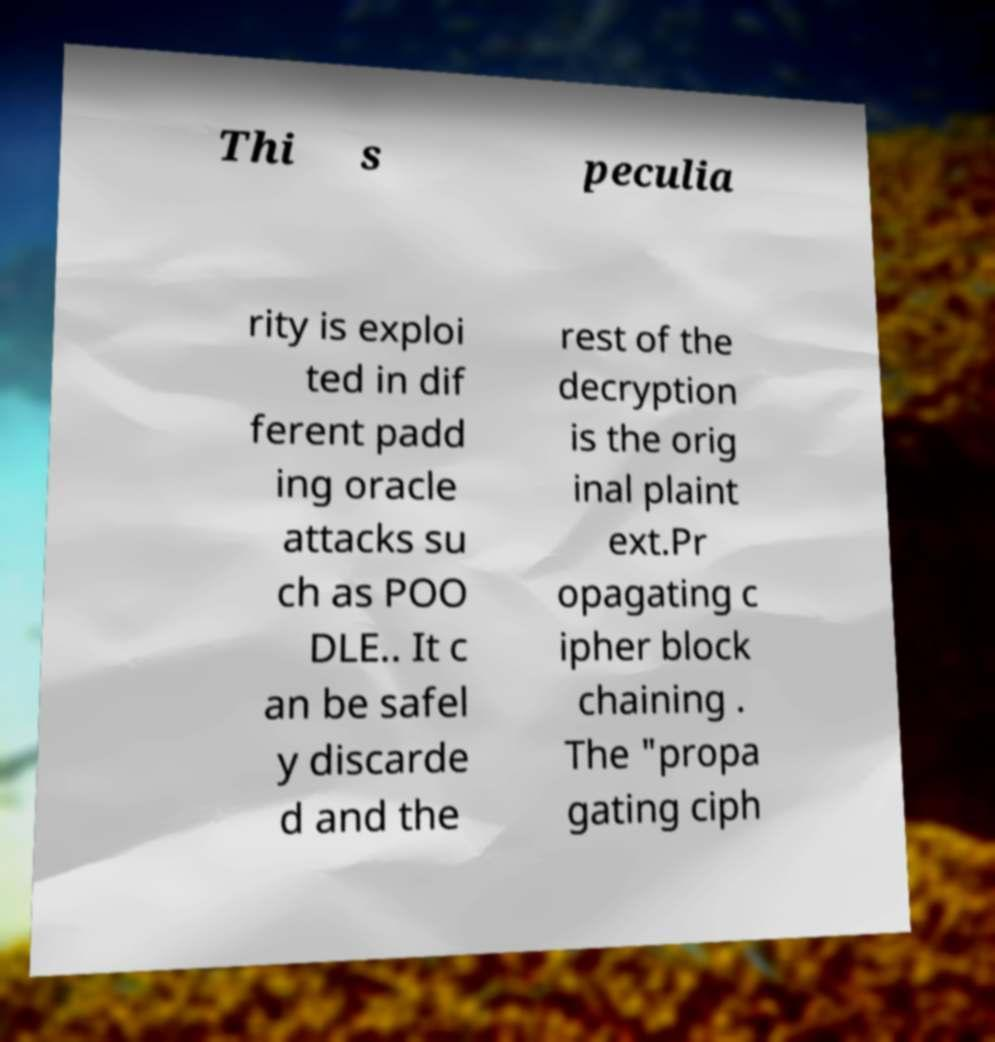Can you accurately transcribe the text from the provided image for me? Thi s peculia rity is exploi ted in dif ferent padd ing oracle attacks su ch as POO DLE.. It c an be safel y discarde d and the rest of the decryption is the orig inal plaint ext.Pr opagating c ipher block chaining . The "propa gating ciph 